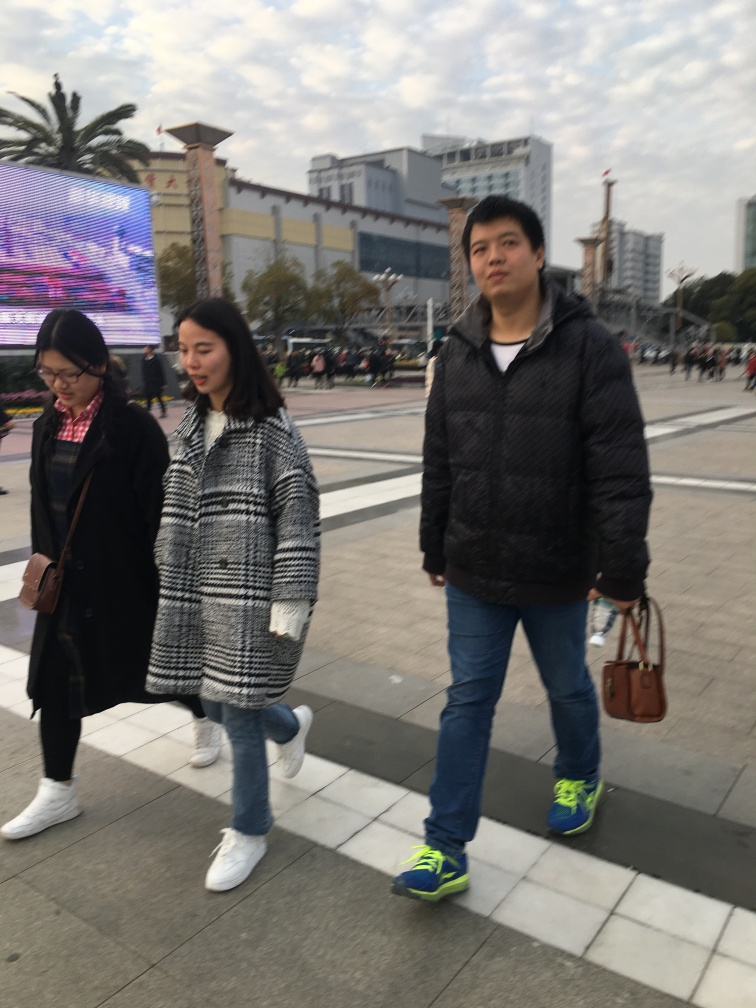What are some possible relationships or narratives that can be inferred about the people in the image? It's intriguing to consider the dynamics at play; the three persons might be friends or family. The central figure's direct gaze towards the camera suggests awareness of being photographed, hinting at a narrative where this moment was spontaneously captured while they were engaged in a leisurely stroll. 